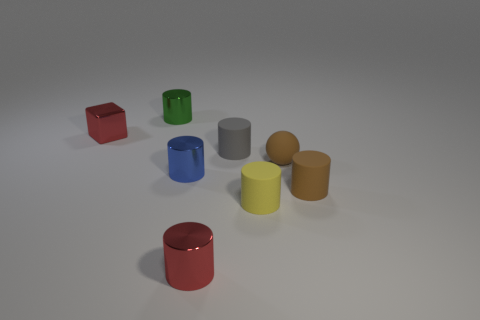Add 2 green things. How many objects exist? 10 Subtract all small red cylinders. How many cylinders are left? 5 Subtract 4 cylinders. How many cylinders are left? 2 Subtract 0 yellow balls. How many objects are left? 8 Subtract all spheres. How many objects are left? 7 Subtract all red spheres. Subtract all purple cylinders. How many spheres are left? 1 Subtract all green cylinders. How many gray cubes are left? 0 Subtract all small cyan metallic spheres. Subtract all rubber spheres. How many objects are left? 7 Add 8 small yellow rubber objects. How many small yellow rubber objects are left? 9 Add 8 small red blocks. How many small red blocks exist? 9 